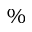Convert formula to latex. <formula><loc_0><loc_0><loc_500><loc_500>\%</formula> 